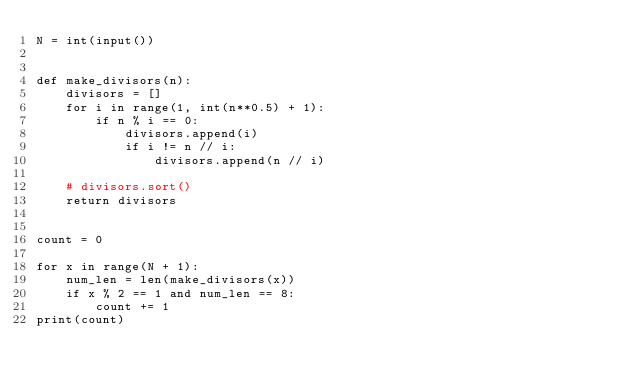Convert code to text. <code><loc_0><loc_0><loc_500><loc_500><_Python_>N = int(input())


def make_divisors(n):
    divisors = []
    for i in range(1, int(n**0.5) + 1):
        if n % i == 0:
            divisors.append(i)
            if i != n // i:
                divisors.append(n // i)

    # divisors.sort()
    return divisors


count = 0

for x in range(N + 1):
    num_len = len(make_divisors(x))
    if x % 2 == 1 and num_len == 8:
        count += 1
print(count)
</code> 